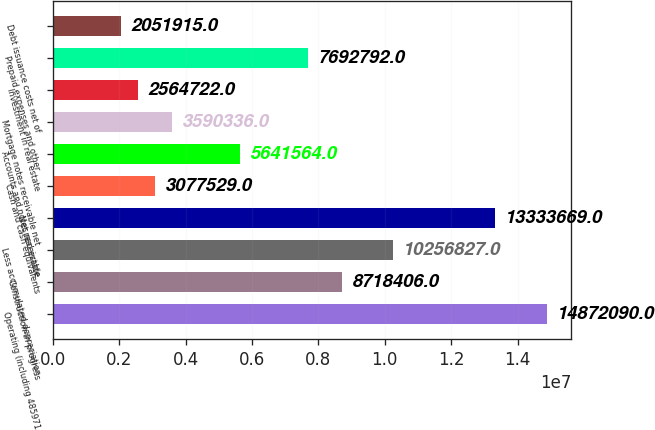Convert chart. <chart><loc_0><loc_0><loc_500><loc_500><bar_chart><fcel>Operating (including 485971<fcel>Construction-in-progress<fcel>Less accumulated depreciation<fcel>Net real estate<fcel>Cash and cash equivalents<fcel>Accounts and notes receivable<fcel>Mortgage notes receivable net<fcel>Investment in real estate<fcel>Prepaid expenses and other<fcel>Debt issuance costs net of<nl><fcel>1.48721e+07<fcel>8.71841e+06<fcel>1.02568e+07<fcel>1.33337e+07<fcel>3.07753e+06<fcel>5.64156e+06<fcel>3.59034e+06<fcel>2.56472e+06<fcel>7.69279e+06<fcel>2.05192e+06<nl></chart> 